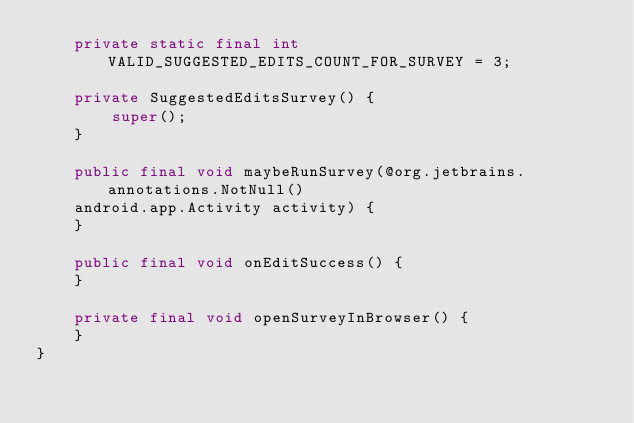Convert code to text. <code><loc_0><loc_0><loc_500><loc_500><_Java_>    private static final int VALID_SUGGESTED_EDITS_COUNT_FOR_SURVEY = 3;
    
    private SuggestedEditsSurvey() {
        super();
    }
    
    public final void maybeRunSurvey(@org.jetbrains.annotations.NotNull()
    android.app.Activity activity) {
    }
    
    public final void onEditSuccess() {
    }
    
    private final void openSurveyInBrowser() {
    }
}</code> 